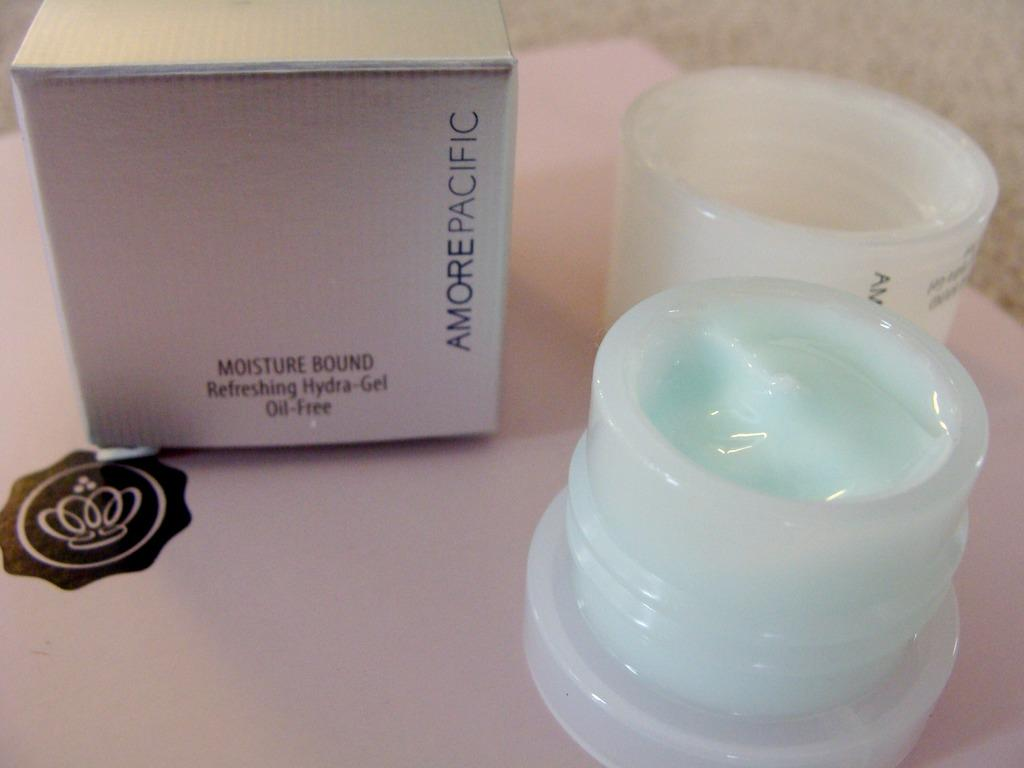<image>
Provide a brief description of the given image. Amore Pacific face cream open on a pink box with a crown 